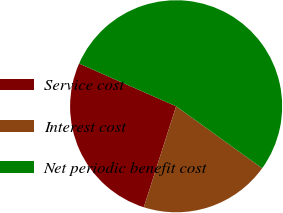Convert chart. <chart><loc_0><loc_0><loc_500><loc_500><pie_chart><fcel>Service cost<fcel>Interest cost<fcel>Net periodic benefit cost<nl><fcel>26.67%<fcel>20.0%<fcel>53.33%<nl></chart> 